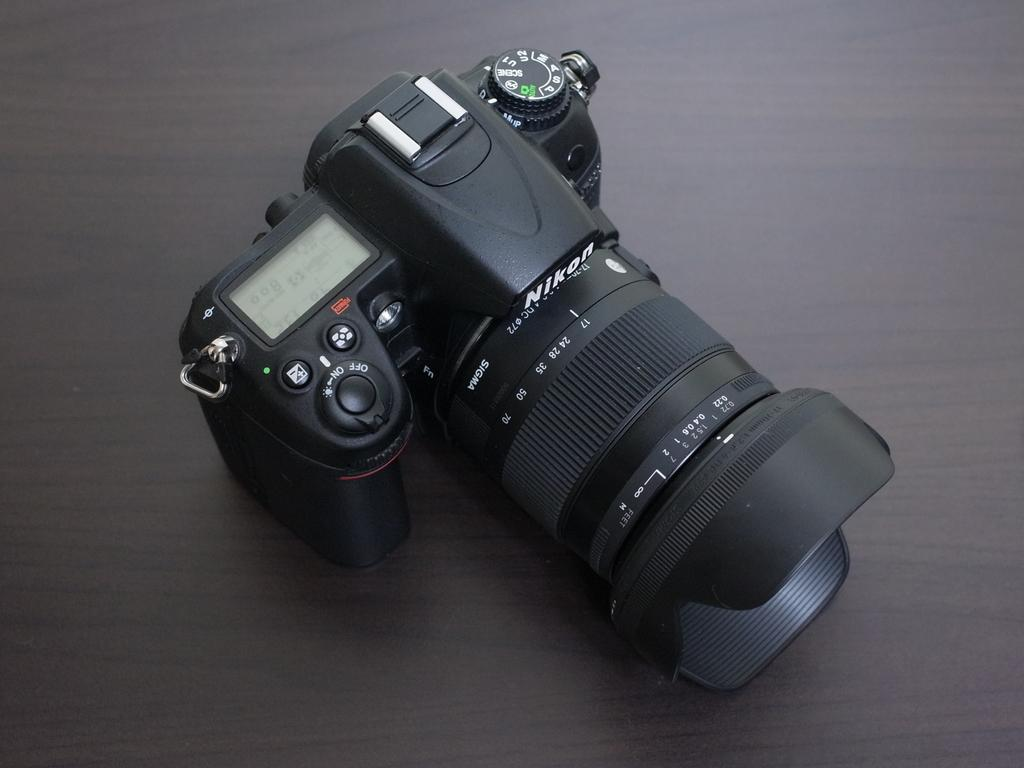<image>
Give a short and clear explanation of the subsequent image. A Nikon camera sits on a wooden table. 